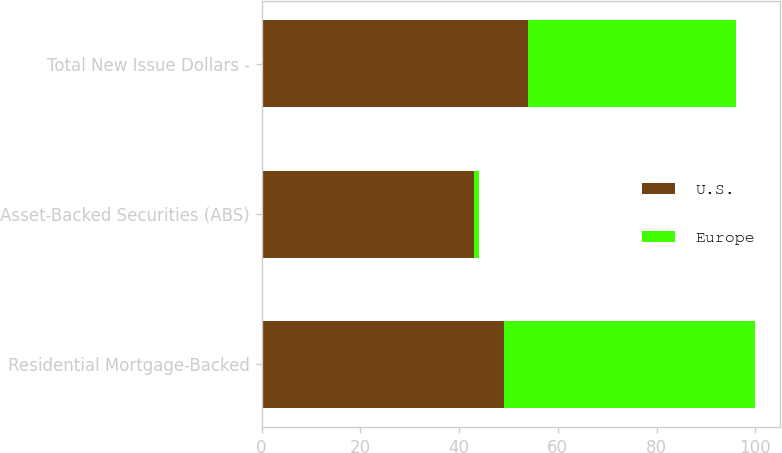<chart> <loc_0><loc_0><loc_500><loc_500><stacked_bar_chart><ecel><fcel>Residential Mortgage-Backed<fcel>Asset-Backed Securities (ABS)<fcel>Total New Issue Dollars -<nl><fcel>U.S.<fcel>49<fcel>43<fcel>54<nl><fcel>Europe<fcel>51<fcel>1<fcel>42<nl></chart> 